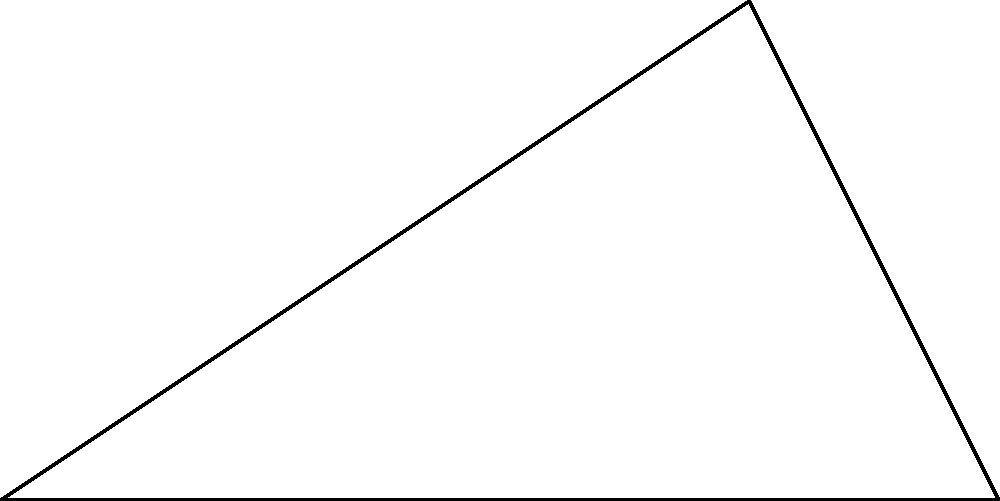During a crucial match at the Athens Olympic Stadium, Panathinaikos striker (point C) receives a pass and is positioned 60 meters from the corner flag (point A) and 80 meters from the opposite corner flag (point B). If the width of the field is 80 meters, what is the distance between the striker and the goal line (represented by line AB)? Let's solve this problem step by step using the Pythagorean theorem:

1) We can represent this situation as a right-angled triangle where:
   - AC = 60m (distance from striker to corner A)
   - AB = 80m (width of the field)
   - BC is the distance we need to find

2) The Pythagorean theorem states that in a right-angled triangle:
   $a^2 + b^2 = c^2$

3) In our case:
   $BC^2 + 60^2 = 80^2$

4) Let's solve for BC:
   $BC^2 = 80^2 - 60^2$
   $BC^2 = 6400 - 3600$
   $BC^2 = 2800$

5) Taking the square root of both sides:
   $BC = \sqrt{2800}$

6) Simplify:
   $BC = 40\sqrt{2}$ meters

Therefore, the striker is $40\sqrt{2}$ meters from the goal line.
Answer: $40\sqrt{2}$ meters 